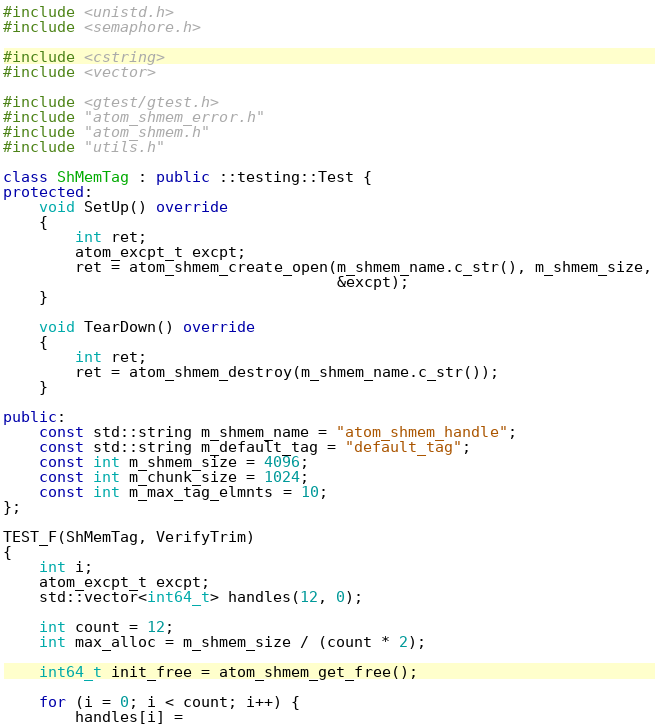<code> <loc_0><loc_0><loc_500><loc_500><_C++_>#include <unistd.h>
#include <semaphore.h>

#include <cstring>
#include <vector>

#include <gtest/gtest.h>
#include "atom_shmem_error.h"
#include "atom_shmem.h"
#include "utils.h"

class ShMemTag : public ::testing::Test {
protected:
    void SetUp() override
    {
        int ret;
        atom_excpt_t excpt;
        ret = atom_shmem_create_open(m_shmem_name.c_str(), m_shmem_size,
                                     &excpt);
    }

    void TearDown() override
    {
        int ret;
        ret = atom_shmem_destroy(m_shmem_name.c_str());
    }

public:
    const std::string m_shmem_name = "atom_shmem_handle";
    const std::string m_default_tag = "default_tag";
    const int m_shmem_size = 4096;
    const int m_chunk_size = 1024;
    const int m_max_tag_elmnts = 10;
};

TEST_F(ShMemTag, VerifyTrim)
{
    int i;
    atom_excpt_t excpt;
    std::vector<int64_t> handles(12, 0);

    int count = 12;
    int max_alloc = m_shmem_size / (count * 2);

    int64_t init_free = atom_shmem_get_free();

    for (i = 0; i < count; i++) {
        handles[i] =</code> 